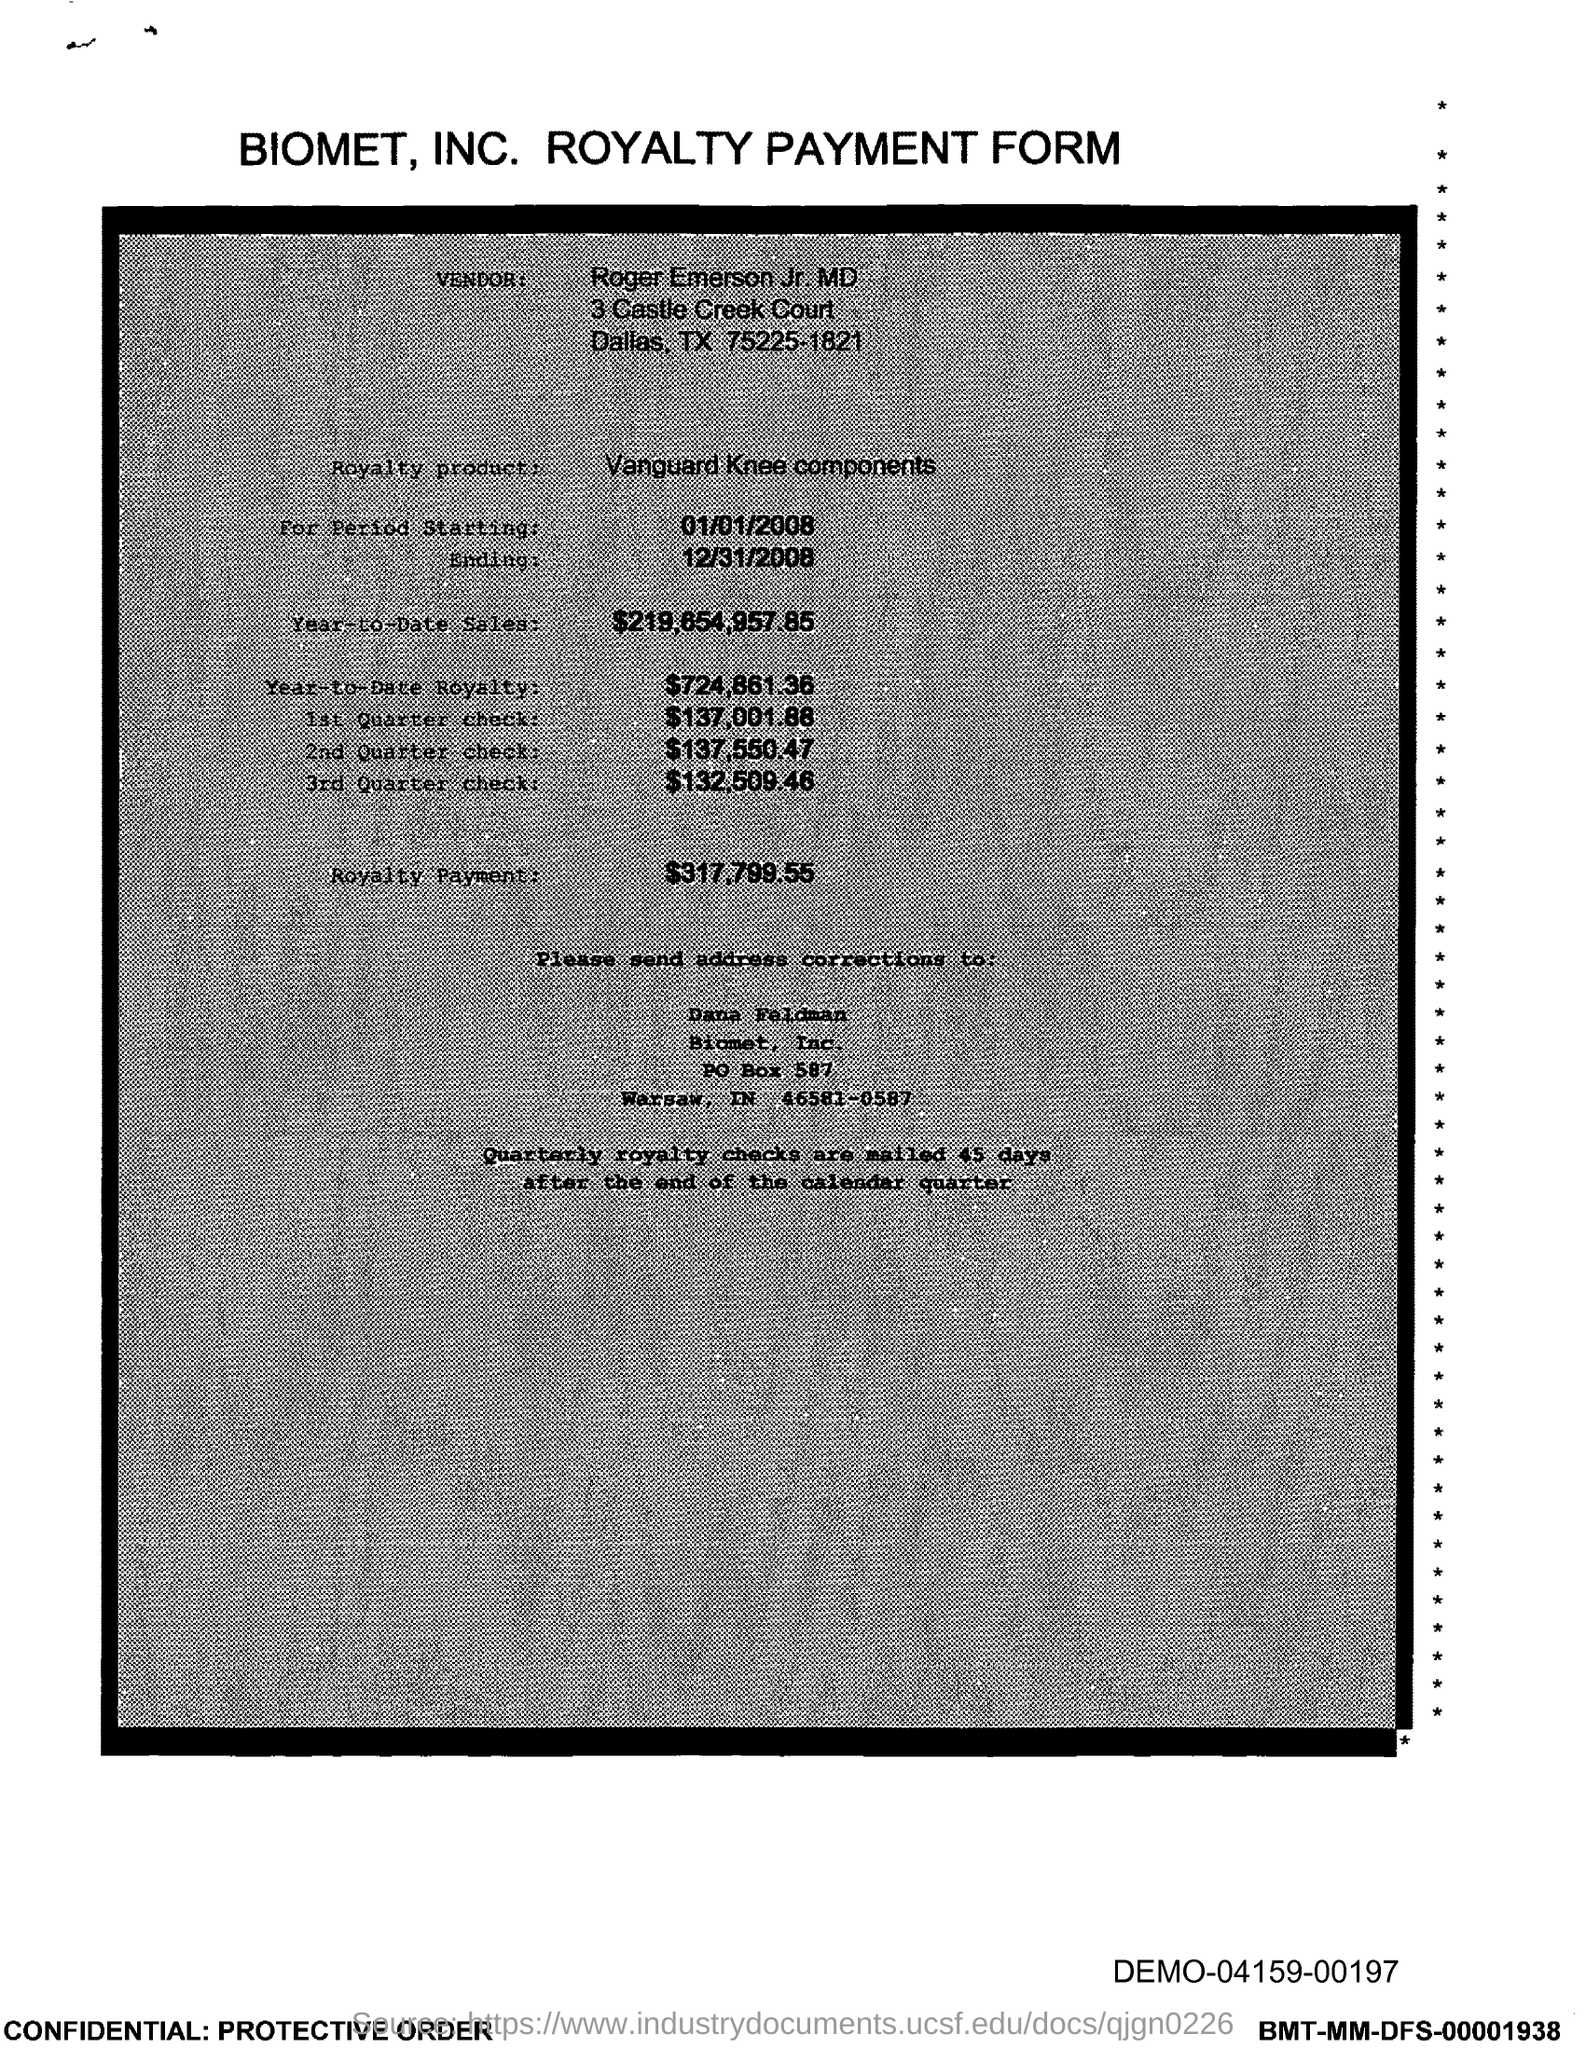What is the form about?
Offer a very short reply. BIOMET, INC. ROYALTY PAYMENT FORM. Who is the vendor?
Your answer should be very brief. Roger Emerson. What is the Royalty product mentioned?
Offer a terse response. Vanguard Knee components. To whom should address corrections be sent?
Make the answer very short. Dana Feldman. What is the royalty payment?
Make the answer very short. $317,799.55. 